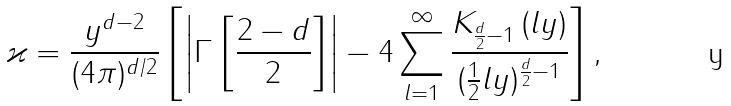<formula> <loc_0><loc_0><loc_500><loc_500>\varkappa = \frac { y ^ { d - 2 } } { ( 4 \pi ) ^ { d / 2 } } \left [ \left | \Gamma \left [ \frac { 2 - d } 2 \right ] \right | - 4 \sum _ { l = 1 } ^ { \infty } \frac { K _ { \frac { d } { 2 } - 1 } \left ( l y \right ) } { ( \frac { 1 } { 2 } l y ) ^ { \frac { d } { 2 } - 1 } } \right ] ,</formula> 